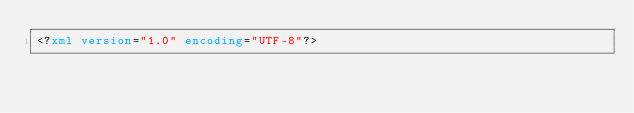Convert code to text. <code><loc_0><loc_0><loc_500><loc_500><_XML_><?xml version="1.0" encoding="UTF-8"?></code> 